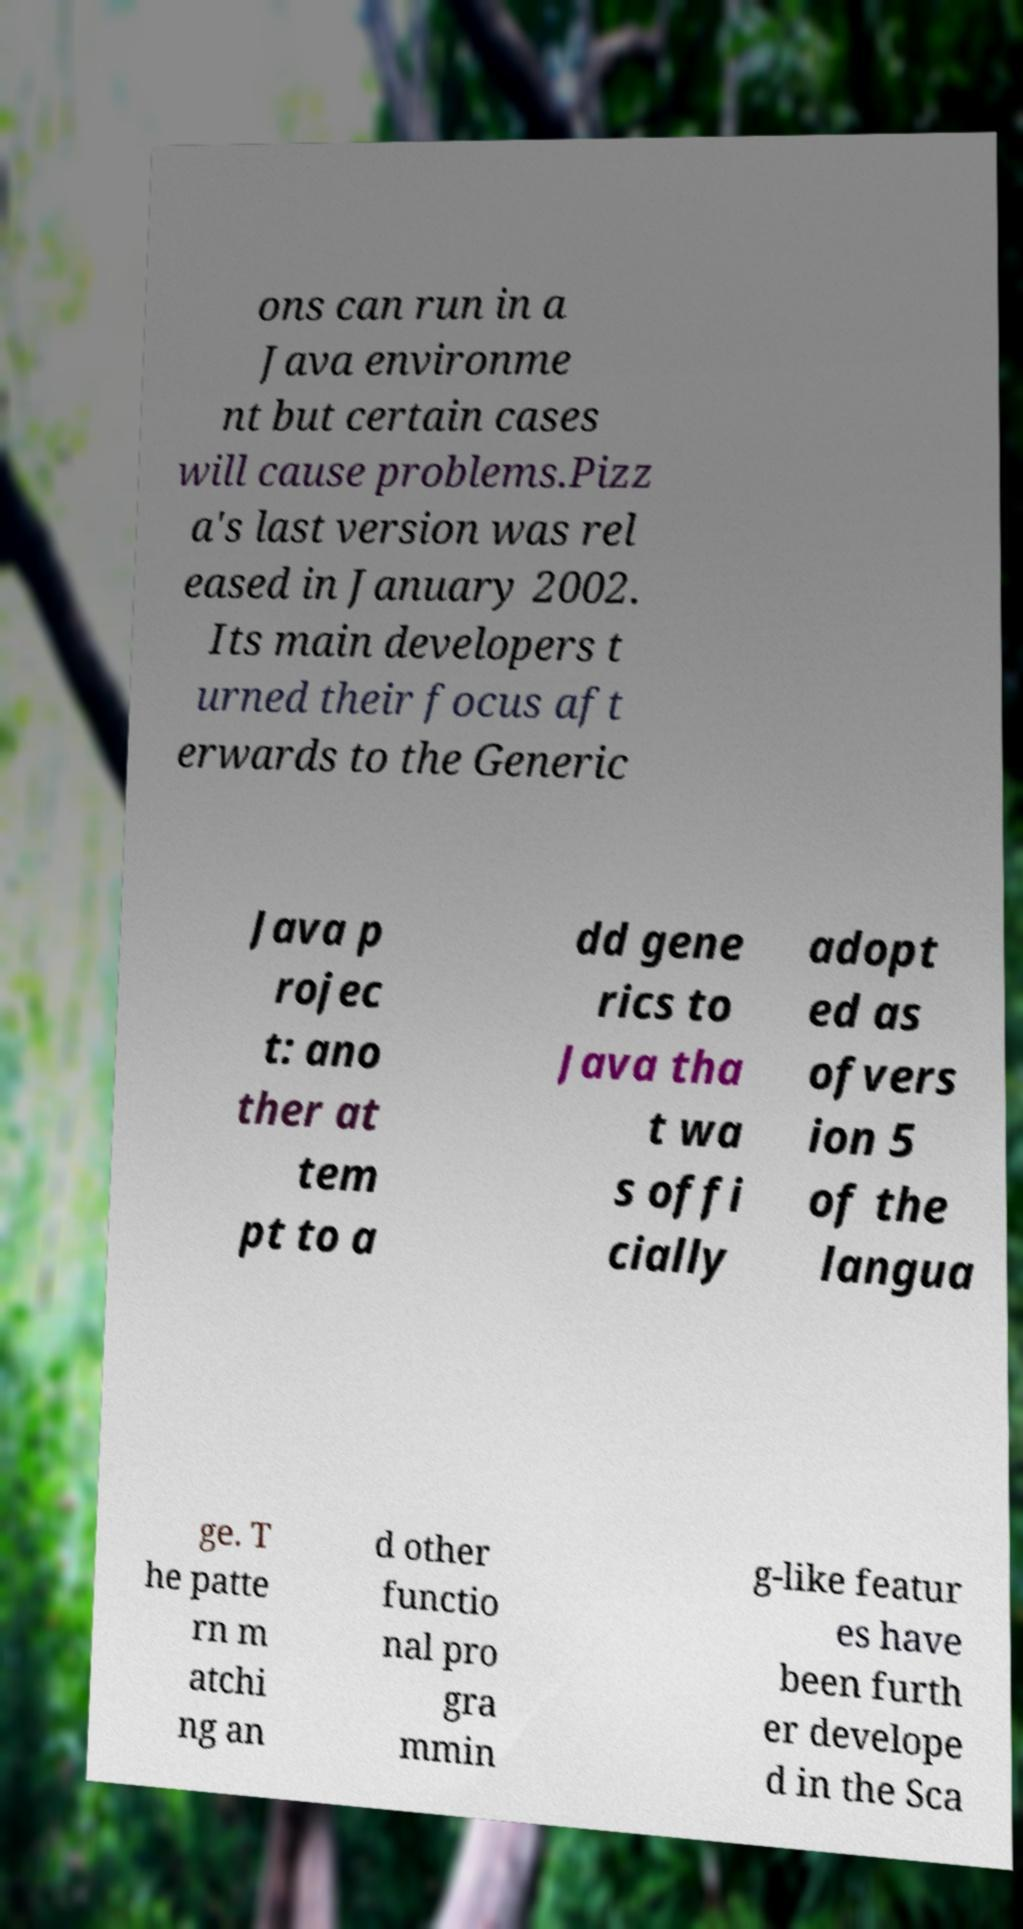Could you assist in decoding the text presented in this image and type it out clearly? ons can run in a Java environme nt but certain cases will cause problems.Pizz a's last version was rel eased in January 2002. Its main developers t urned their focus aft erwards to the Generic Java p rojec t: ano ther at tem pt to a dd gene rics to Java tha t wa s offi cially adopt ed as ofvers ion 5 of the langua ge. T he patte rn m atchi ng an d other functio nal pro gra mmin g-like featur es have been furth er develope d in the Sca 